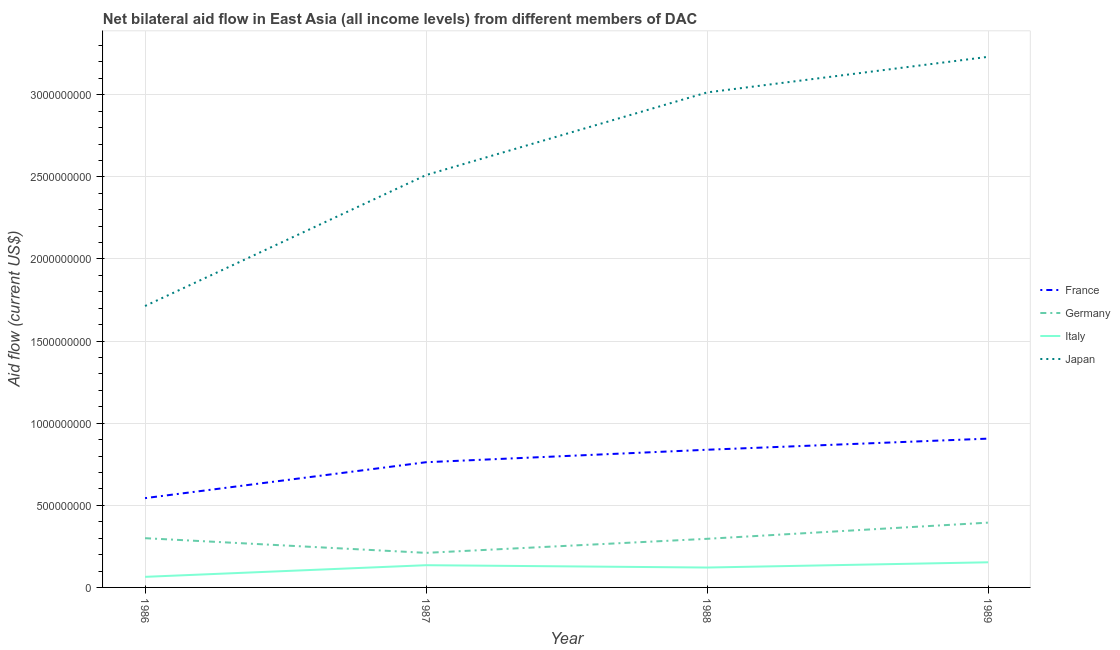How many different coloured lines are there?
Offer a terse response. 4. Is the number of lines equal to the number of legend labels?
Make the answer very short. Yes. What is the amount of aid given by france in 1989?
Ensure brevity in your answer.  9.06e+08. Across all years, what is the maximum amount of aid given by japan?
Your answer should be compact. 3.23e+09. Across all years, what is the minimum amount of aid given by italy?
Provide a short and direct response. 6.44e+07. What is the total amount of aid given by germany in the graph?
Provide a succinct answer. 1.20e+09. What is the difference between the amount of aid given by germany in 1986 and that in 1987?
Make the answer very short. 8.94e+07. What is the difference between the amount of aid given by italy in 1989 and the amount of aid given by japan in 1988?
Provide a short and direct response. -2.86e+09. What is the average amount of aid given by germany per year?
Offer a terse response. 3.00e+08. In the year 1989, what is the difference between the amount of aid given by italy and amount of aid given by japan?
Keep it short and to the point. -3.08e+09. What is the ratio of the amount of aid given by italy in 1986 to that in 1988?
Make the answer very short. 0.53. Is the difference between the amount of aid given by germany in 1986 and 1988 greater than the difference between the amount of aid given by france in 1986 and 1988?
Provide a succinct answer. Yes. What is the difference between the highest and the second highest amount of aid given by japan?
Give a very brief answer. 2.17e+08. What is the difference between the highest and the lowest amount of aid given by france?
Your answer should be compact. 3.62e+08. Is the sum of the amount of aid given by germany in 1988 and 1989 greater than the maximum amount of aid given by france across all years?
Keep it short and to the point. No. Is it the case that in every year, the sum of the amount of aid given by italy and amount of aid given by germany is greater than the sum of amount of aid given by japan and amount of aid given by france?
Provide a short and direct response. No. Is it the case that in every year, the sum of the amount of aid given by france and amount of aid given by germany is greater than the amount of aid given by italy?
Your response must be concise. Yes. Does the amount of aid given by italy monotonically increase over the years?
Your answer should be compact. No. What is the difference between two consecutive major ticks on the Y-axis?
Your answer should be very brief. 5.00e+08. Where does the legend appear in the graph?
Make the answer very short. Center right. How many legend labels are there?
Your answer should be very brief. 4. What is the title of the graph?
Offer a very short reply. Net bilateral aid flow in East Asia (all income levels) from different members of DAC. What is the label or title of the Y-axis?
Offer a very short reply. Aid flow (current US$). What is the Aid flow (current US$) in France in 1986?
Offer a very short reply. 5.44e+08. What is the Aid flow (current US$) in Germany in 1986?
Your response must be concise. 3.00e+08. What is the Aid flow (current US$) of Italy in 1986?
Give a very brief answer. 6.44e+07. What is the Aid flow (current US$) in Japan in 1986?
Offer a terse response. 1.71e+09. What is the Aid flow (current US$) in France in 1987?
Your answer should be compact. 7.62e+08. What is the Aid flow (current US$) in Germany in 1987?
Keep it short and to the point. 2.10e+08. What is the Aid flow (current US$) of Italy in 1987?
Offer a terse response. 1.35e+08. What is the Aid flow (current US$) in Japan in 1987?
Provide a succinct answer. 2.51e+09. What is the Aid flow (current US$) in France in 1988?
Ensure brevity in your answer.  8.38e+08. What is the Aid flow (current US$) in Germany in 1988?
Your answer should be compact. 2.96e+08. What is the Aid flow (current US$) in Italy in 1988?
Your response must be concise. 1.21e+08. What is the Aid flow (current US$) of Japan in 1988?
Your answer should be compact. 3.01e+09. What is the Aid flow (current US$) of France in 1989?
Make the answer very short. 9.06e+08. What is the Aid flow (current US$) in Germany in 1989?
Your answer should be compact. 3.95e+08. What is the Aid flow (current US$) of Italy in 1989?
Keep it short and to the point. 1.53e+08. What is the Aid flow (current US$) in Japan in 1989?
Give a very brief answer. 3.23e+09. Across all years, what is the maximum Aid flow (current US$) of France?
Offer a terse response. 9.06e+08. Across all years, what is the maximum Aid flow (current US$) in Germany?
Make the answer very short. 3.95e+08. Across all years, what is the maximum Aid flow (current US$) in Italy?
Your answer should be very brief. 1.53e+08. Across all years, what is the maximum Aid flow (current US$) in Japan?
Your response must be concise. 3.23e+09. Across all years, what is the minimum Aid flow (current US$) of France?
Offer a terse response. 5.44e+08. Across all years, what is the minimum Aid flow (current US$) in Germany?
Your response must be concise. 2.10e+08. Across all years, what is the minimum Aid flow (current US$) of Italy?
Ensure brevity in your answer.  6.44e+07. Across all years, what is the minimum Aid flow (current US$) in Japan?
Your answer should be compact. 1.71e+09. What is the total Aid flow (current US$) of France in the graph?
Your response must be concise. 3.05e+09. What is the total Aid flow (current US$) of Germany in the graph?
Keep it short and to the point. 1.20e+09. What is the total Aid flow (current US$) of Italy in the graph?
Your response must be concise. 4.74e+08. What is the total Aid flow (current US$) in Japan in the graph?
Your answer should be very brief. 1.05e+1. What is the difference between the Aid flow (current US$) of France in 1986 and that in 1987?
Your answer should be very brief. -2.19e+08. What is the difference between the Aid flow (current US$) of Germany in 1986 and that in 1987?
Offer a terse response. 8.94e+07. What is the difference between the Aid flow (current US$) in Italy in 1986 and that in 1987?
Keep it short and to the point. -7.09e+07. What is the difference between the Aid flow (current US$) in Japan in 1986 and that in 1987?
Ensure brevity in your answer.  -7.97e+08. What is the difference between the Aid flow (current US$) in France in 1986 and that in 1988?
Give a very brief answer. -2.95e+08. What is the difference between the Aid flow (current US$) of Germany in 1986 and that in 1988?
Give a very brief answer. 3.85e+06. What is the difference between the Aid flow (current US$) in Italy in 1986 and that in 1988?
Provide a succinct answer. -5.67e+07. What is the difference between the Aid flow (current US$) of Japan in 1986 and that in 1988?
Offer a very short reply. -1.30e+09. What is the difference between the Aid flow (current US$) of France in 1986 and that in 1989?
Give a very brief answer. -3.62e+08. What is the difference between the Aid flow (current US$) of Germany in 1986 and that in 1989?
Provide a succinct answer. -9.46e+07. What is the difference between the Aid flow (current US$) in Italy in 1986 and that in 1989?
Your answer should be very brief. -8.86e+07. What is the difference between the Aid flow (current US$) in Japan in 1986 and that in 1989?
Your answer should be very brief. -1.52e+09. What is the difference between the Aid flow (current US$) in France in 1987 and that in 1988?
Provide a short and direct response. -7.59e+07. What is the difference between the Aid flow (current US$) of Germany in 1987 and that in 1988?
Offer a terse response. -8.56e+07. What is the difference between the Aid flow (current US$) in Italy in 1987 and that in 1988?
Provide a short and direct response. 1.42e+07. What is the difference between the Aid flow (current US$) of Japan in 1987 and that in 1988?
Your answer should be very brief. -5.03e+08. What is the difference between the Aid flow (current US$) of France in 1987 and that in 1989?
Provide a succinct answer. -1.44e+08. What is the difference between the Aid flow (current US$) of Germany in 1987 and that in 1989?
Ensure brevity in your answer.  -1.84e+08. What is the difference between the Aid flow (current US$) in Italy in 1987 and that in 1989?
Give a very brief answer. -1.77e+07. What is the difference between the Aid flow (current US$) of Japan in 1987 and that in 1989?
Your response must be concise. -7.20e+08. What is the difference between the Aid flow (current US$) of France in 1988 and that in 1989?
Ensure brevity in your answer.  -6.77e+07. What is the difference between the Aid flow (current US$) of Germany in 1988 and that in 1989?
Keep it short and to the point. -9.85e+07. What is the difference between the Aid flow (current US$) of Italy in 1988 and that in 1989?
Provide a short and direct response. -3.19e+07. What is the difference between the Aid flow (current US$) in Japan in 1988 and that in 1989?
Keep it short and to the point. -2.17e+08. What is the difference between the Aid flow (current US$) of France in 1986 and the Aid flow (current US$) of Germany in 1987?
Give a very brief answer. 3.33e+08. What is the difference between the Aid flow (current US$) in France in 1986 and the Aid flow (current US$) in Italy in 1987?
Provide a succinct answer. 4.08e+08. What is the difference between the Aid flow (current US$) of France in 1986 and the Aid flow (current US$) of Japan in 1987?
Offer a terse response. -1.97e+09. What is the difference between the Aid flow (current US$) in Germany in 1986 and the Aid flow (current US$) in Italy in 1987?
Make the answer very short. 1.65e+08. What is the difference between the Aid flow (current US$) in Germany in 1986 and the Aid flow (current US$) in Japan in 1987?
Your response must be concise. -2.21e+09. What is the difference between the Aid flow (current US$) of Italy in 1986 and the Aid flow (current US$) of Japan in 1987?
Make the answer very short. -2.45e+09. What is the difference between the Aid flow (current US$) in France in 1986 and the Aid flow (current US$) in Germany in 1988?
Your response must be concise. 2.48e+08. What is the difference between the Aid flow (current US$) of France in 1986 and the Aid flow (current US$) of Italy in 1988?
Give a very brief answer. 4.23e+08. What is the difference between the Aid flow (current US$) in France in 1986 and the Aid flow (current US$) in Japan in 1988?
Your response must be concise. -2.47e+09. What is the difference between the Aid flow (current US$) of Germany in 1986 and the Aid flow (current US$) of Italy in 1988?
Give a very brief answer. 1.79e+08. What is the difference between the Aid flow (current US$) in Germany in 1986 and the Aid flow (current US$) in Japan in 1988?
Make the answer very short. -2.71e+09. What is the difference between the Aid flow (current US$) in Italy in 1986 and the Aid flow (current US$) in Japan in 1988?
Ensure brevity in your answer.  -2.95e+09. What is the difference between the Aid flow (current US$) in France in 1986 and the Aid flow (current US$) in Germany in 1989?
Your answer should be compact. 1.49e+08. What is the difference between the Aid flow (current US$) in France in 1986 and the Aid flow (current US$) in Italy in 1989?
Offer a terse response. 3.91e+08. What is the difference between the Aid flow (current US$) of France in 1986 and the Aid flow (current US$) of Japan in 1989?
Your answer should be compact. -2.69e+09. What is the difference between the Aid flow (current US$) of Germany in 1986 and the Aid flow (current US$) of Italy in 1989?
Keep it short and to the point. 1.47e+08. What is the difference between the Aid flow (current US$) in Germany in 1986 and the Aid flow (current US$) in Japan in 1989?
Keep it short and to the point. -2.93e+09. What is the difference between the Aid flow (current US$) of Italy in 1986 and the Aid flow (current US$) of Japan in 1989?
Your response must be concise. -3.17e+09. What is the difference between the Aid flow (current US$) of France in 1987 and the Aid flow (current US$) of Germany in 1988?
Your answer should be compact. 4.66e+08. What is the difference between the Aid flow (current US$) of France in 1987 and the Aid flow (current US$) of Italy in 1988?
Offer a very short reply. 6.41e+08. What is the difference between the Aid flow (current US$) in France in 1987 and the Aid flow (current US$) in Japan in 1988?
Offer a terse response. -2.25e+09. What is the difference between the Aid flow (current US$) in Germany in 1987 and the Aid flow (current US$) in Italy in 1988?
Give a very brief answer. 8.93e+07. What is the difference between the Aid flow (current US$) in Germany in 1987 and the Aid flow (current US$) in Japan in 1988?
Keep it short and to the point. -2.80e+09. What is the difference between the Aid flow (current US$) of Italy in 1987 and the Aid flow (current US$) of Japan in 1988?
Ensure brevity in your answer.  -2.88e+09. What is the difference between the Aid flow (current US$) in France in 1987 and the Aid flow (current US$) in Germany in 1989?
Keep it short and to the point. 3.68e+08. What is the difference between the Aid flow (current US$) in France in 1987 and the Aid flow (current US$) in Italy in 1989?
Ensure brevity in your answer.  6.09e+08. What is the difference between the Aid flow (current US$) of France in 1987 and the Aid flow (current US$) of Japan in 1989?
Your answer should be very brief. -2.47e+09. What is the difference between the Aid flow (current US$) in Germany in 1987 and the Aid flow (current US$) in Italy in 1989?
Provide a short and direct response. 5.74e+07. What is the difference between the Aid flow (current US$) in Germany in 1987 and the Aid flow (current US$) in Japan in 1989?
Provide a short and direct response. -3.02e+09. What is the difference between the Aid flow (current US$) in Italy in 1987 and the Aid flow (current US$) in Japan in 1989?
Offer a terse response. -3.10e+09. What is the difference between the Aid flow (current US$) in France in 1988 and the Aid flow (current US$) in Germany in 1989?
Provide a short and direct response. 4.44e+08. What is the difference between the Aid flow (current US$) of France in 1988 and the Aid flow (current US$) of Italy in 1989?
Provide a short and direct response. 6.85e+08. What is the difference between the Aid flow (current US$) of France in 1988 and the Aid flow (current US$) of Japan in 1989?
Keep it short and to the point. -2.39e+09. What is the difference between the Aid flow (current US$) of Germany in 1988 and the Aid flow (current US$) of Italy in 1989?
Give a very brief answer. 1.43e+08. What is the difference between the Aid flow (current US$) of Germany in 1988 and the Aid flow (current US$) of Japan in 1989?
Your response must be concise. -2.94e+09. What is the difference between the Aid flow (current US$) in Italy in 1988 and the Aid flow (current US$) in Japan in 1989?
Ensure brevity in your answer.  -3.11e+09. What is the average Aid flow (current US$) of France per year?
Keep it short and to the point. 7.63e+08. What is the average Aid flow (current US$) of Germany per year?
Provide a succinct answer. 3.00e+08. What is the average Aid flow (current US$) of Italy per year?
Keep it short and to the point. 1.18e+08. What is the average Aid flow (current US$) of Japan per year?
Keep it short and to the point. 2.62e+09. In the year 1986, what is the difference between the Aid flow (current US$) in France and Aid flow (current US$) in Germany?
Your answer should be very brief. 2.44e+08. In the year 1986, what is the difference between the Aid flow (current US$) in France and Aid flow (current US$) in Italy?
Your answer should be very brief. 4.79e+08. In the year 1986, what is the difference between the Aid flow (current US$) in France and Aid flow (current US$) in Japan?
Your answer should be compact. -1.17e+09. In the year 1986, what is the difference between the Aid flow (current US$) in Germany and Aid flow (current US$) in Italy?
Your response must be concise. 2.35e+08. In the year 1986, what is the difference between the Aid flow (current US$) of Germany and Aid flow (current US$) of Japan?
Your answer should be very brief. -1.41e+09. In the year 1986, what is the difference between the Aid flow (current US$) in Italy and Aid flow (current US$) in Japan?
Your answer should be very brief. -1.65e+09. In the year 1987, what is the difference between the Aid flow (current US$) in France and Aid flow (current US$) in Germany?
Offer a very short reply. 5.52e+08. In the year 1987, what is the difference between the Aid flow (current US$) in France and Aid flow (current US$) in Italy?
Provide a short and direct response. 6.27e+08. In the year 1987, what is the difference between the Aid flow (current US$) of France and Aid flow (current US$) of Japan?
Your answer should be very brief. -1.75e+09. In the year 1987, what is the difference between the Aid flow (current US$) in Germany and Aid flow (current US$) in Italy?
Your answer should be very brief. 7.51e+07. In the year 1987, what is the difference between the Aid flow (current US$) of Germany and Aid flow (current US$) of Japan?
Provide a short and direct response. -2.30e+09. In the year 1987, what is the difference between the Aid flow (current US$) of Italy and Aid flow (current US$) of Japan?
Offer a very short reply. -2.38e+09. In the year 1988, what is the difference between the Aid flow (current US$) in France and Aid flow (current US$) in Germany?
Your response must be concise. 5.42e+08. In the year 1988, what is the difference between the Aid flow (current US$) in France and Aid flow (current US$) in Italy?
Ensure brevity in your answer.  7.17e+08. In the year 1988, what is the difference between the Aid flow (current US$) in France and Aid flow (current US$) in Japan?
Your answer should be very brief. -2.18e+09. In the year 1988, what is the difference between the Aid flow (current US$) in Germany and Aid flow (current US$) in Italy?
Your answer should be compact. 1.75e+08. In the year 1988, what is the difference between the Aid flow (current US$) in Germany and Aid flow (current US$) in Japan?
Provide a short and direct response. -2.72e+09. In the year 1988, what is the difference between the Aid flow (current US$) of Italy and Aid flow (current US$) of Japan?
Make the answer very short. -2.89e+09. In the year 1989, what is the difference between the Aid flow (current US$) in France and Aid flow (current US$) in Germany?
Provide a short and direct response. 5.12e+08. In the year 1989, what is the difference between the Aid flow (current US$) of France and Aid flow (current US$) of Italy?
Keep it short and to the point. 7.53e+08. In the year 1989, what is the difference between the Aid flow (current US$) of France and Aid flow (current US$) of Japan?
Provide a short and direct response. -2.32e+09. In the year 1989, what is the difference between the Aid flow (current US$) of Germany and Aid flow (current US$) of Italy?
Your answer should be compact. 2.41e+08. In the year 1989, what is the difference between the Aid flow (current US$) of Germany and Aid flow (current US$) of Japan?
Your response must be concise. -2.84e+09. In the year 1989, what is the difference between the Aid flow (current US$) of Italy and Aid flow (current US$) of Japan?
Ensure brevity in your answer.  -3.08e+09. What is the ratio of the Aid flow (current US$) in France in 1986 to that in 1987?
Your response must be concise. 0.71. What is the ratio of the Aid flow (current US$) in Germany in 1986 to that in 1987?
Ensure brevity in your answer.  1.42. What is the ratio of the Aid flow (current US$) of Italy in 1986 to that in 1987?
Your answer should be very brief. 0.48. What is the ratio of the Aid flow (current US$) in Japan in 1986 to that in 1987?
Offer a very short reply. 0.68. What is the ratio of the Aid flow (current US$) of France in 1986 to that in 1988?
Provide a short and direct response. 0.65. What is the ratio of the Aid flow (current US$) in Italy in 1986 to that in 1988?
Your answer should be compact. 0.53. What is the ratio of the Aid flow (current US$) in Japan in 1986 to that in 1988?
Your response must be concise. 0.57. What is the ratio of the Aid flow (current US$) in France in 1986 to that in 1989?
Give a very brief answer. 0.6. What is the ratio of the Aid flow (current US$) in Germany in 1986 to that in 1989?
Keep it short and to the point. 0.76. What is the ratio of the Aid flow (current US$) of Italy in 1986 to that in 1989?
Your answer should be very brief. 0.42. What is the ratio of the Aid flow (current US$) in Japan in 1986 to that in 1989?
Ensure brevity in your answer.  0.53. What is the ratio of the Aid flow (current US$) in France in 1987 to that in 1988?
Offer a very short reply. 0.91. What is the ratio of the Aid flow (current US$) in Germany in 1987 to that in 1988?
Give a very brief answer. 0.71. What is the ratio of the Aid flow (current US$) in Italy in 1987 to that in 1988?
Offer a very short reply. 1.12. What is the ratio of the Aid flow (current US$) of Japan in 1987 to that in 1988?
Your answer should be compact. 0.83. What is the ratio of the Aid flow (current US$) in France in 1987 to that in 1989?
Provide a short and direct response. 0.84. What is the ratio of the Aid flow (current US$) of Germany in 1987 to that in 1989?
Make the answer very short. 0.53. What is the ratio of the Aid flow (current US$) of Italy in 1987 to that in 1989?
Ensure brevity in your answer.  0.88. What is the ratio of the Aid flow (current US$) of Japan in 1987 to that in 1989?
Provide a short and direct response. 0.78. What is the ratio of the Aid flow (current US$) in France in 1988 to that in 1989?
Make the answer very short. 0.93. What is the ratio of the Aid flow (current US$) in Germany in 1988 to that in 1989?
Provide a short and direct response. 0.75. What is the ratio of the Aid flow (current US$) in Italy in 1988 to that in 1989?
Offer a very short reply. 0.79. What is the ratio of the Aid flow (current US$) in Japan in 1988 to that in 1989?
Make the answer very short. 0.93. What is the difference between the highest and the second highest Aid flow (current US$) in France?
Offer a very short reply. 6.77e+07. What is the difference between the highest and the second highest Aid flow (current US$) in Germany?
Offer a very short reply. 9.46e+07. What is the difference between the highest and the second highest Aid flow (current US$) of Italy?
Provide a succinct answer. 1.77e+07. What is the difference between the highest and the second highest Aid flow (current US$) in Japan?
Offer a terse response. 2.17e+08. What is the difference between the highest and the lowest Aid flow (current US$) in France?
Provide a succinct answer. 3.62e+08. What is the difference between the highest and the lowest Aid flow (current US$) in Germany?
Your answer should be very brief. 1.84e+08. What is the difference between the highest and the lowest Aid flow (current US$) of Italy?
Offer a very short reply. 8.86e+07. What is the difference between the highest and the lowest Aid flow (current US$) in Japan?
Offer a very short reply. 1.52e+09. 